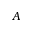Convert formula to latex. <formula><loc_0><loc_0><loc_500><loc_500>A</formula> 